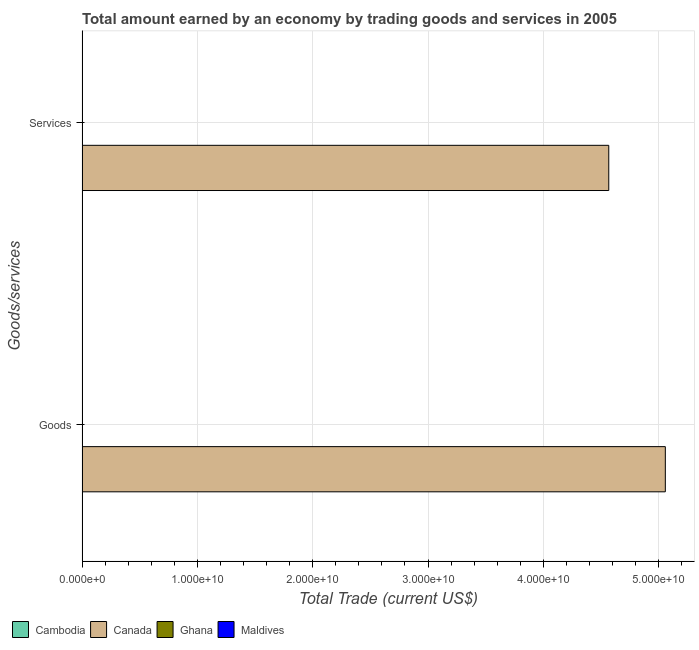How many different coloured bars are there?
Ensure brevity in your answer.  1. Are the number of bars on each tick of the Y-axis equal?
Offer a terse response. Yes. What is the label of the 1st group of bars from the top?
Your answer should be compact. Services. What is the amount earned by trading goods in Maldives?
Make the answer very short. 0. Across all countries, what is the maximum amount earned by trading services?
Your answer should be very brief. 4.57e+1. In which country was the amount earned by trading goods maximum?
Provide a short and direct response. Canada. What is the total amount earned by trading goods in the graph?
Make the answer very short. 5.06e+1. What is the difference between the amount earned by trading goods in Canada and the amount earned by trading services in Maldives?
Keep it short and to the point. 5.06e+1. What is the average amount earned by trading goods per country?
Make the answer very short. 1.26e+1. What is the difference between the amount earned by trading services and amount earned by trading goods in Canada?
Provide a short and direct response. -4.90e+09. In how many countries, is the amount earned by trading goods greater than the average amount earned by trading goods taken over all countries?
Make the answer very short. 1. How many countries are there in the graph?
Your answer should be compact. 4. Are the values on the major ticks of X-axis written in scientific E-notation?
Ensure brevity in your answer.  Yes. Does the graph contain grids?
Keep it short and to the point. Yes. How are the legend labels stacked?
Provide a succinct answer. Horizontal. What is the title of the graph?
Ensure brevity in your answer.  Total amount earned by an economy by trading goods and services in 2005. Does "Euro area" appear as one of the legend labels in the graph?
Make the answer very short. No. What is the label or title of the X-axis?
Offer a terse response. Total Trade (current US$). What is the label or title of the Y-axis?
Keep it short and to the point. Goods/services. What is the Total Trade (current US$) of Canada in Goods?
Keep it short and to the point. 5.06e+1. What is the Total Trade (current US$) of Ghana in Goods?
Make the answer very short. 0. What is the Total Trade (current US$) of Maldives in Goods?
Keep it short and to the point. 0. What is the Total Trade (current US$) of Canada in Services?
Make the answer very short. 4.57e+1. What is the Total Trade (current US$) of Ghana in Services?
Provide a succinct answer. 0. What is the Total Trade (current US$) of Maldives in Services?
Your answer should be very brief. 0. Across all Goods/services, what is the maximum Total Trade (current US$) in Canada?
Your answer should be compact. 5.06e+1. Across all Goods/services, what is the minimum Total Trade (current US$) in Canada?
Your answer should be very brief. 4.57e+1. What is the total Total Trade (current US$) of Cambodia in the graph?
Your response must be concise. 0. What is the total Total Trade (current US$) of Canada in the graph?
Keep it short and to the point. 9.62e+1. What is the total Total Trade (current US$) in Maldives in the graph?
Your answer should be very brief. 0. What is the difference between the Total Trade (current US$) in Canada in Goods and that in Services?
Give a very brief answer. 4.90e+09. What is the average Total Trade (current US$) in Canada per Goods/services?
Provide a succinct answer. 4.81e+1. What is the average Total Trade (current US$) of Maldives per Goods/services?
Your answer should be very brief. 0. What is the ratio of the Total Trade (current US$) in Canada in Goods to that in Services?
Your answer should be very brief. 1.11. What is the difference between the highest and the second highest Total Trade (current US$) in Canada?
Your response must be concise. 4.90e+09. What is the difference between the highest and the lowest Total Trade (current US$) in Canada?
Make the answer very short. 4.90e+09. 